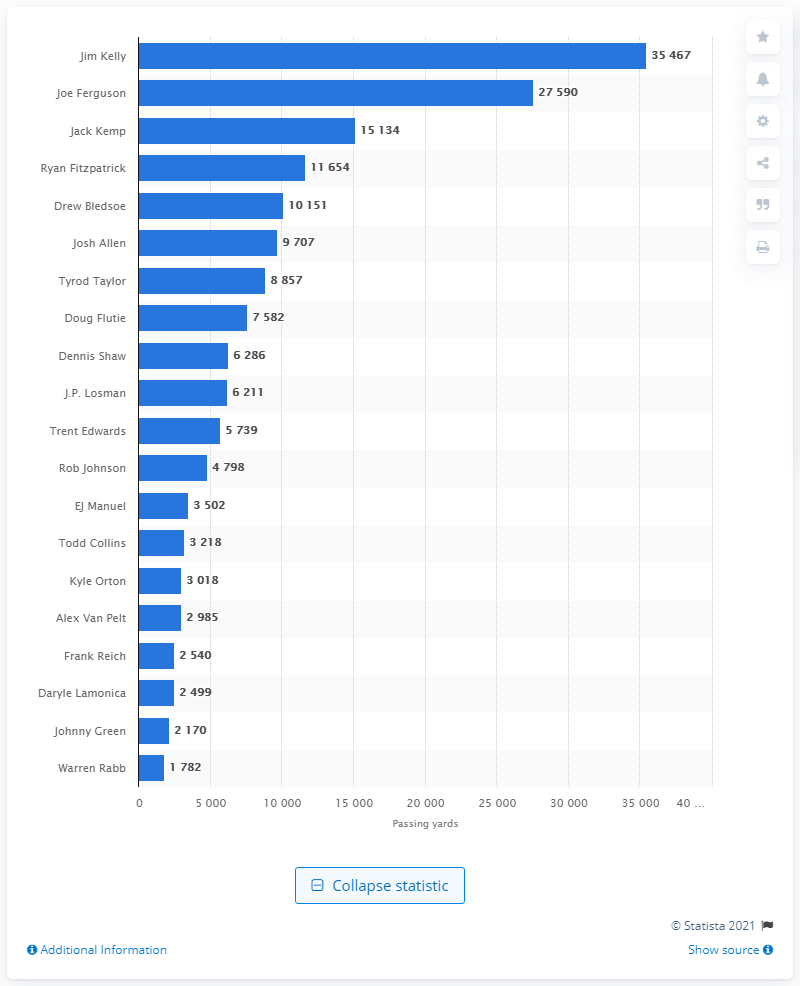Draw attention to some important aspects in this diagram. Jim Kelly is the career passing leader of the Buffalo Bills. 